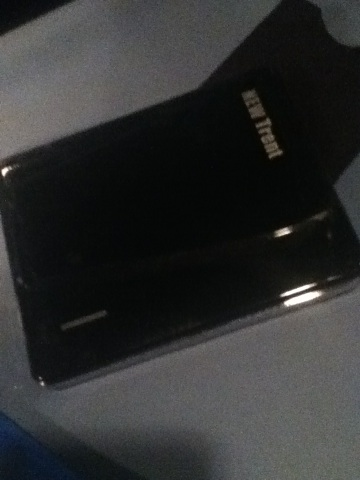This piece of technology looks sleek. What are some other devices similar in purpose? Similar devices to an external hard drive include USB flash drives, SSDs (Solid State Drives), and cloud storage solutions. Each has its own advantages; for example, SSDs offer faster data transfer speeds compared to traditional hard drives, while cloud storage allows you to access your data from anywhere with an internet connection. What makes SSDs preferable over traditional hard drives? SSDs (Solid State Drives) are generally preferable over traditional hard drives due to several key factors. SSDs have faster read and write speeds, which significantly improves system performance and reduces load times. They are also more durable because they have no moving parts, making them less prone to physical damage. Additionally, SSDs are often more energy-efficient, contributing to longer battery life in laptops. 